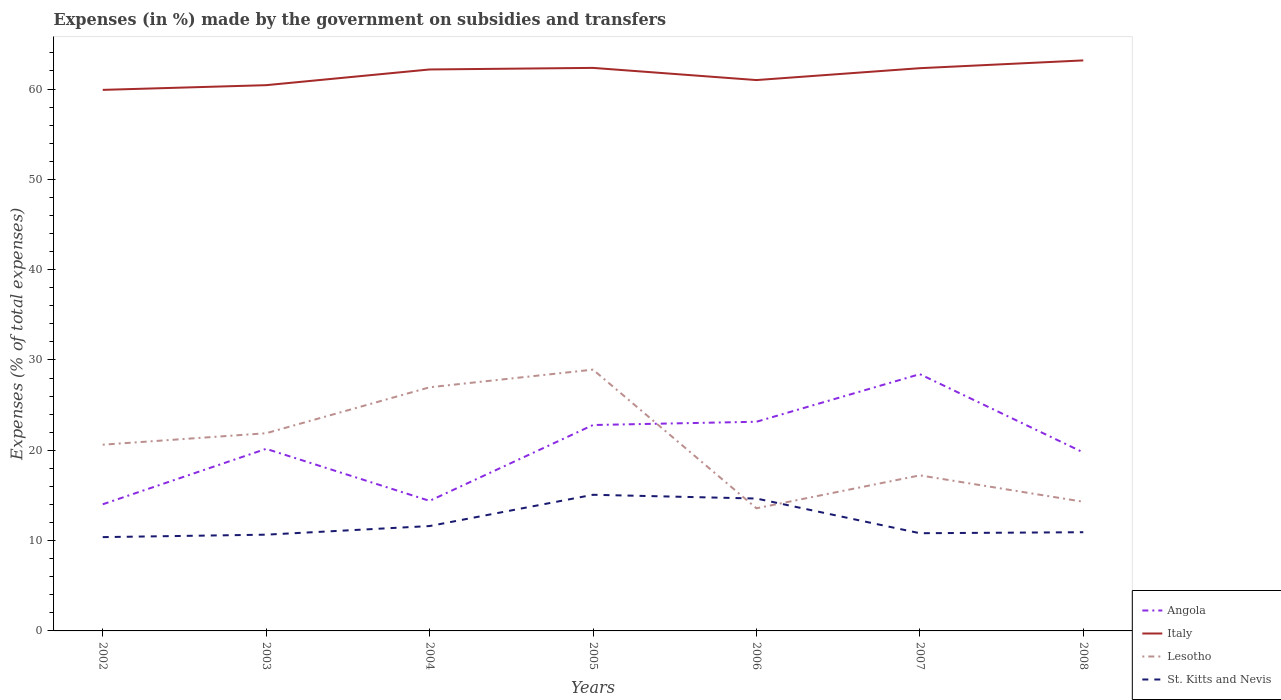How many different coloured lines are there?
Make the answer very short. 4. Does the line corresponding to Lesotho intersect with the line corresponding to Angola?
Offer a terse response. Yes. Is the number of lines equal to the number of legend labels?
Make the answer very short. Yes. Across all years, what is the maximum percentage of expenses made by the government on subsidies and transfers in Lesotho?
Ensure brevity in your answer.  13.58. In which year was the percentage of expenses made by the government on subsidies and transfers in Lesotho maximum?
Make the answer very short. 2006. What is the total percentage of expenses made by the government on subsidies and transfers in St. Kitts and Nevis in the graph?
Offer a very short reply. 0.79. What is the difference between the highest and the second highest percentage of expenses made by the government on subsidies and transfers in Angola?
Your answer should be compact. 14.41. Is the percentage of expenses made by the government on subsidies and transfers in Angola strictly greater than the percentage of expenses made by the government on subsidies and transfers in Italy over the years?
Your answer should be very brief. Yes. How many years are there in the graph?
Provide a succinct answer. 7. What is the difference between two consecutive major ticks on the Y-axis?
Ensure brevity in your answer.  10. Are the values on the major ticks of Y-axis written in scientific E-notation?
Give a very brief answer. No. Does the graph contain grids?
Your answer should be very brief. No. How are the legend labels stacked?
Your answer should be compact. Vertical. What is the title of the graph?
Make the answer very short. Expenses (in %) made by the government on subsidies and transfers. What is the label or title of the Y-axis?
Your answer should be very brief. Expenses (% of total expenses). What is the Expenses (% of total expenses) of Angola in 2002?
Offer a terse response. 14.02. What is the Expenses (% of total expenses) in Italy in 2002?
Make the answer very short. 59.91. What is the Expenses (% of total expenses) of Lesotho in 2002?
Provide a short and direct response. 20.62. What is the Expenses (% of total expenses) of St. Kitts and Nevis in 2002?
Your answer should be compact. 10.39. What is the Expenses (% of total expenses) in Angola in 2003?
Your answer should be very brief. 20.16. What is the Expenses (% of total expenses) of Italy in 2003?
Provide a succinct answer. 60.43. What is the Expenses (% of total expenses) in Lesotho in 2003?
Make the answer very short. 21.89. What is the Expenses (% of total expenses) of St. Kitts and Nevis in 2003?
Your answer should be very brief. 10.66. What is the Expenses (% of total expenses) in Angola in 2004?
Ensure brevity in your answer.  14.4. What is the Expenses (% of total expenses) in Italy in 2004?
Your answer should be compact. 62.17. What is the Expenses (% of total expenses) in Lesotho in 2004?
Provide a short and direct response. 26.98. What is the Expenses (% of total expenses) in St. Kitts and Nevis in 2004?
Make the answer very short. 11.61. What is the Expenses (% of total expenses) in Angola in 2005?
Offer a terse response. 22.8. What is the Expenses (% of total expenses) in Italy in 2005?
Keep it short and to the point. 62.34. What is the Expenses (% of total expenses) of Lesotho in 2005?
Offer a terse response. 28.93. What is the Expenses (% of total expenses) in St. Kitts and Nevis in 2005?
Provide a succinct answer. 15.08. What is the Expenses (% of total expenses) in Angola in 2006?
Provide a short and direct response. 23.16. What is the Expenses (% of total expenses) in Italy in 2006?
Provide a short and direct response. 60.99. What is the Expenses (% of total expenses) in Lesotho in 2006?
Your response must be concise. 13.58. What is the Expenses (% of total expenses) of St. Kitts and Nevis in 2006?
Make the answer very short. 14.66. What is the Expenses (% of total expenses) of Angola in 2007?
Your answer should be compact. 28.43. What is the Expenses (% of total expenses) of Italy in 2007?
Provide a short and direct response. 62.31. What is the Expenses (% of total expenses) of Lesotho in 2007?
Your response must be concise. 17.23. What is the Expenses (% of total expenses) in St. Kitts and Nevis in 2007?
Keep it short and to the point. 10.82. What is the Expenses (% of total expenses) in Angola in 2008?
Ensure brevity in your answer.  19.76. What is the Expenses (% of total expenses) in Italy in 2008?
Make the answer very short. 63.17. What is the Expenses (% of total expenses) of Lesotho in 2008?
Make the answer very short. 14.3. What is the Expenses (% of total expenses) of St. Kitts and Nevis in 2008?
Provide a succinct answer. 10.93. Across all years, what is the maximum Expenses (% of total expenses) of Angola?
Your answer should be compact. 28.43. Across all years, what is the maximum Expenses (% of total expenses) of Italy?
Give a very brief answer. 63.17. Across all years, what is the maximum Expenses (% of total expenses) of Lesotho?
Your response must be concise. 28.93. Across all years, what is the maximum Expenses (% of total expenses) in St. Kitts and Nevis?
Provide a succinct answer. 15.08. Across all years, what is the minimum Expenses (% of total expenses) of Angola?
Your response must be concise. 14.02. Across all years, what is the minimum Expenses (% of total expenses) in Italy?
Make the answer very short. 59.91. Across all years, what is the minimum Expenses (% of total expenses) of Lesotho?
Your answer should be compact. 13.58. Across all years, what is the minimum Expenses (% of total expenses) of St. Kitts and Nevis?
Provide a short and direct response. 10.39. What is the total Expenses (% of total expenses) of Angola in the graph?
Offer a very short reply. 142.74. What is the total Expenses (% of total expenses) of Italy in the graph?
Provide a succinct answer. 431.32. What is the total Expenses (% of total expenses) of Lesotho in the graph?
Provide a short and direct response. 143.52. What is the total Expenses (% of total expenses) in St. Kitts and Nevis in the graph?
Your response must be concise. 84.14. What is the difference between the Expenses (% of total expenses) of Angola in 2002 and that in 2003?
Your answer should be very brief. -6.14. What is the difference between the Expenses (% of total expenses) of Italy in 2002 and that in 2003?
Offer a terse response. -0.52. What is the difference between the Expenses (% of total expenses) of Lesotho in 2002 and that in 2003?
Give a very brief answer. -1.27. What is the difference between the Expenses (% of total expenses) in St. Kitts and Nevis in 2002 and that in 2003?
Offer a very short reply. -0.27. What is the difference between the Expenses (% of total expenses) in Angola in 2002 and that in 2004?
Your answer should be compact. -0.38. What is the difference between the Expenses (% of total expenses) of Italy in 2002 and that in 2004?
Offer a terse response. -2.26. What is the difference between the Expenses (% of total expenses) of Lesotho in 2002 and that in 2004?
Give a very brief answer. -6.36. What is the difference between the Expenses (% of total expenses) of St. Kitts and Nevis in 2002 and that in 2004?
Provide a short and direct response. -1.23. What is the difference between the Expenses (% of total expenses) in Angola in 2002 and that in 2005?
Give a very brief answer. -8.78. What is the difference between the Expenses (% of total expenses) of Italy in 2002 and that in 2005?
Your answer should be compact. -2.43. What is the difference between the Expenses (% of total expenses) of Lesotho in 2002 and that in 2005?
Your response must be concise. -8.31. What is the difference between the Expenses (% of total expenses) of St. Kitts and Nevis in 2002 and that in 2005?
Give a very brief answer. -4.69. What is the difference between the Expenses (% of total expenses) in Angola in 2002 and that in 2006?
Give a very brief answer. -9.14. What is the difference between the Expenses (% of total expenses) in Italy in 2002 and that in 2006?
Give a very brief answer. -1.09. What is the difference between the Expenses (% of total expenses) of Lesotho in 2002 and that in 2006?
Keep it short and to the point. 7.04. What is the difference between the Expenses (% of total expenses) of St. Kitts and Nevis in 2002 and that in 2006?
Offer a terse response. -4.27. What is the difference between the Expenses (% of total expenses) of Angola in 2002 and that in 2007?
Your answer should be very brief. -14.41. What is the difference between the Expenses (% of total expenses) in Italy in 2002 and that in 2007?
Your answer should be very brief. -2.4. What is the difference between the Expenses (% of total expenses) in Lesotho in 2002 and that in 2007?
Provide a short and direct response. 3.39. What is the difference between the Expenses (% of total expenses) of St. Kitts and Nevis in 2002 and that in 2007?
Provide a succinct answer. -0.43. What is the difference between the Expenses (% of total expenses) in Angola in 2002 and that in 2008?
Give a very brief answer. -5.74. What is the difference between the Expenses (% of total expenses) of Italy in 2002 and that in 2008?
Ensure brevity in your answer.  -3.26. What is the difference between the Expenses (% of total expenses) of Lesotho in 2002 and that in 2008?
Ensure brevity in your answer.  6.32. What is the difference between the Expenses (% of total expenses) in St. Kitts and Nevis in 2002 and that in 2008?
Give a very brief answer. -0.54. What is the difference between the Expenses (% of total expenses) in Angola in 2003 and that in 2004?
Give a very brief answer. 5.76. What is the difference between the Expenses (% of total expenses) of Italy in 2003 and that in 2004?
Keep it short and to the point. -1.74. What is the difference between the Expenses (% of total expenses) in Lesotho in 2003 and that in 2004?
Offer a very short reply. -5.09. What is the difference between the Expenses (% of total expenses) of St. Kitts and Nevis in 2003 and that in 2004?
Your answer should be very brief. -0.95. What is the difference between the Expenses (% of total expenses) in Angola in 2003 and that in 2005?
Your answer should be compact. -2.64. What is the difference between the Expenses (% of total expenses) in Italy in 2003 and that in 2005?
Provide a succinct answer. -1.91. What is the difference between the Expenses (% of total expenses) of Lesotho in 2003 and that in 2005?
Make the answer very short. -7.04. What is the difference between the Expenses (% of total expenses) of St. Kitts and Nevis in 2003 and that in 2005?
Keep it short and to the point. -4.42. What is the difference between the Expenses (% of total expenses) of Angola in 2003 and that in 2006?
Offer a terse response. -3. What is the difference between the Expenses (% of total expenses) of Italy in 2003 and that in 2006?
Give a very brief answer. -0.56. What is the difference between the Expenses (% of total expenses) of Lesotho in 2003 and that in 2006?
Give a very brief answer. 8.31. What is the difference between the Expenses (% of total expenses) of St. Kitts and Nevis in 2003 and that in 2006?
Keep it short and to the point. -4. What is the difference between the Expenses (% of total expenses) of Angola in 2003 and that in 2007?
Provide a short and direct response. -8.27. What is the difference between the Expenses (% of total expenses) of Italy in 2003 and that in 2007?
Your answer should be very brief. -1.88. What is the difference between the Expenses (% of total expenses) in Lesotho in 2003 and that in 2007?
Provide a succinct answer. 4.66. What is the difference between the Expenses (% of total expenses) of St. Kitts and Nevis in 2003 and that in 2007?
Provide a short and direct response. -0.16. What is the difference between the Expenses (% of total expenses) of Angola in 2003 and that in 2008?
Offer a very short reply. 0.4. What is the difference between the Expenses (% of total expenses) in Italy in 2003 and that in 2008?
Your answer should be very brief. -2.74. What is the difference between the Expenses (% of total expenses) in Lesotho in 2003 and that in 2008?
Provide a succinct answer. 7.59. What is the difference between the Expenses (% of total expenses) in St. Kitts and Nevis in 2003 and that in 2008?
Provide a short and direct response. -0.27. What is the difference between the Expenses (% of total expenses) of Angola in 2004 and that in 2005?
Your response must be concise. -8.4. What is the difference between the Expenses (% of total expenses) of Italy in 2004 and that in 2005?
Your answer should be compact. -0.17. What is the difference between the Expenses (% of total expenses) of Lesotho in 2004 and that in 2005?
Make the answer very short. -1.95. What is the difference between the Expenses (% of total expenses) in St. Kitts and Nevis in 2004 and that in 2005?
Offer a terse response. -3.46. What is the difference between the Expenses (% of total expenses) of Angola in 2004 and that in 2006?
Your answer should be very brief. -8.76. What is the difference between the Expenses (% of total expenses) in Italy in 2004 and that in 2006?
Your answer should be compact. 1.17. What is the difference between the Expenses (% of total expenses) of Lesotho in 2004 and that in 2006?
Offer a very short reply. 13.4. What is the difference between the Expenses (% of total expenses) of St. Kitts and Nevis in 2004 and that in 2006?
Ensure brevity in your answer.  -3.05. What is the difference between the Expenses (% of total expenses) in Angola in 2004 and that in 2007?
Keep it short and to the point. -14.03. What is the difference between the Expenses (% of total expenses) of Italy in 2004 and that in 2007?
Offer a very short reply. -0.14. What is the difference between the Expenses (% of total expenses) of Lesotho in 2004 and that in 2007?
Offer a very short reply. 9.75. What is the difference between the Expenses (% of total expenses) of St. Kitts and Nevis in 2004 and that in 2007?
Offer a terse response. 0.79. What is the difference between the Expenses (% of total expenses) of Angola in 2004 and that in 2008?
Offer a terse response. -5.36. What is the difference between the Expenses (% of total expenses) of Italy in 2004 and that in 2008?
Your answer should be compact. -1. What is the difference between the Expenses (% of total expenses) of Lesotho in 2004 and that in 2008?
Offer a terse response. 12.68. What is the difference between the Expenses (% of total expenses) in St. Kitts and Nevis in 2004 and that in 2008?
Ensure brevity in your answer.  0.68. What is the difference between the Expenses (% of total expenses) in Angola in 2005 and that in 2006?
Your response must be concise. -0.36. What is the difference between the Expenses (% of total expenses) in Italy in 2005 and that in 2006?
Offer a terse response. 1.35. What is the difference between the Expenses (% of total expenses) in Lesotho in 2005 and that in 2006?
Keep it short and to the point. 15.35. What is the difference between the Expenses (% of total expenses) of St. Kitts and Nevis in 2005 and that in 2006?
Your answer should be very brief. 0.42. What is the difference between the Expenses (% of total expenses) in Angola in 2005 and that in 2007?
Provide a short and direct response. -5.63. What is the difference between the Expenses (% of total expenses) in Italy in 2005 and that in 2007?
Provide a succinct answer. 0.03. What is the difference between the Expenses (% of total expenses) of Lesotho in 2005 and that in 2007?
Your response must be concise. 11.7. What is the difference between the Expenses (% of total expenses) in St. Kitts and Nevis in 2005 and that in 2007?
Ensure brevity in your answer.  4.26. What is the difference between the Expenses (% of total expenses) in Angola in 2005 and that in 2008?
Make the answer very short. 3.04. What is the difference between the Expenses (% of total expenses) of Italy in 2005 and that in 2008?
Your answer should be compact. -0.83. What is the difference between the Expenses (% of total expenses) of Lesotho in 2005 and that in 2008?
Provide a succinct answer. 14.63. What is the difference between the Expenses (% of total expenses) of St. Kitts and Nevis in 2005 and that in 2008?
Offer a terse response. 4.15. What is the difference between the Expenses (% of total expenses) in Angola in 2006 and that in 2007?
Keep it short and to the point. -5.27. What is the difference between the Expenses (% of total expenses) of Italy in 2006 and that in 2007?
Give a very brief answer. -1.32. What is the difference between the Expenses (% of total expenses) of Lesotho in 2006 and that in 2007?
Your answer should be compact. -3.65. What is the difference between the Expenses (% of total expenses) in St. Kitts and Nevis in 2006 and that in 2007?
Keep it short and to the point. 3.84. What is the difference between the Expenses (% of total expenses) of Angola in 2006 and that in 2008?
Offer a terse response. 3.4. What is the difference between the Expenses (% of total expenses) of Italy in 2006 and that in 2008?
Offer a terse response. -2.18. What is the difference between the Expenses (% of total expenses) of Lesotho in 2006 and that in 2008?
Provide a succinct answer. -0.72. What is the difference between the Expenses (% of total expenses) of St. Kitts and Nevis in 2006 and that in 2008?
Provide a succinct answer. 3.73. What is the difference between the Expenses (% of total expenses) in Angola in 2007 and that in 2008?
Give a very brief answer. 8.67. What is the difference between the Expenses (% of total expenses) of Italy in 2007 and that in 2008?
Your response must be concise. -0.86. What is the difference between the Expenses (% of total expenses) of Lesotho in 2007 and that in 2008?
Offer a very short reply. 2.92. What is the difference between the Expenses (% of total expenses) of St. Kitts and Nevis in 2007 and that in 2008?
Provide a short and direct response. -0.11. What is the difference between the Expenses (% of total expenses) of Angola in 2002 and the Expenses (% of total expenses) of Italy in 2003?
Your answer should be very brief. -46.41. What is the difference between the Expenses (% of total expenses) in Angola in 2002 and the Expenses (% of total expenses) in Lesotho in 2003?
Your answer should be very brief. -7.87. What is the difference between the Expenses (% of total expenses) of Angola in 2002 and the Expenses (% of total expenses) of St. Kitts and Nevis in 2003?
Your answer should be compact. 3.37. What is the difference between the Expenses (% of total expenses) of Italy in 2002 and the Expenses (% of total expenses) of Lesotho in 2003?
Your answer should be very brief. 38.02. What is the difference between the Expenses (% of total expenses) of Italy in 2002 and the Expenses (% of total expenses) of St. Kitts and Nevis in 2003?
Offer a terse response. 49.25. What is the difference between the Expenses (% of total expenses) of Lesotho in 2002 and the Expenses (% of total expenses) of St. Kitts and Nevis in 2003?
Keep it short and to the point. 9.96. What is the difference between the Expenses (% of total expenses) of Angola in 2002 and the Expenses (% of total expenses) of Italy in 2004?
Make the answer very short. -48.14. What is the difference between the Expenses (% of total expenses) in Angola in 2002 and the Expenses (% of total expenses) in Lesotho in 2004?
Your response must be concise. -12.95. What is the difference between the Expenses (% of total expenses) in Angola in 2002 and the Expenses (% of total expenses) in St. Kitts and Nevis in 2004?
Offer a terse response. 2.41. What is the difference between the Expenses (% of total expenses) of Italy in 2002 and the Expenses (% of total expenses) of Lesotho in 2004?
Your response must be concise. 32.93. What is the difference between the Expenses (% of total expenses) of Italy in 2002 and the Expenses (% of total expenses) of St. Kitts and Nevis in 2004?
Offer a terse response. 48.3. What is the difference between the Expenses (% of total expenses) of Lesotho in 2002 and the Expenses (% of total expenses) of St. Kitts and Nevis in 2004?
Offer a very short reply. 9.01. What is the difference between the Expenses (% of total expenses) of Angola in 2002 and the Expenses (% of total expenses) of Italy in 2005?
Your answer should be compact. -48.32. What is the difference between the Expenses (% of total expenses) in Angola in 2002 and the Expenses (% of total expenses) in Lesotho in 2005?
Offer a very short reply. -14.91. What is the difference between the Expenses (% of total expenses) in Angola in 2002 and the Expenses (% of total expenses) in St. Kitts and Nevis in 2005?
Offer a terse response. -1.05. What is the difference between the Expenses (% of total expenses) of Italy in 2002 and the Expenses (% of total expenses) of Lesotho in 2005?
Your answer should be compact. 30.98. What is the difference between the Expenses (% of total expenses) of Italy in 2002 and the Expenses (% of total expenses) of St. Kitts and Nevis in 2005?
Your answer should be compact. 44.83. What is the difference between the Expenses (% of total expenses) of Lesotho in 2002 and the Expenses (% of total expenses) of St. Kitts and Nevis in 2005?
Provide a short and direct response. 5.54. What is the difference between the Expenses (% of total expenses) in Angola in 2002 and the Expenses (% of total expenses) in Italy in 2006?
Your response must be concise. -46.97. What is the difference between the Expenses (% of total expenses) of Angola in 2002 and the Expenses (% of total expenses) of Lesotho in 2006?
Keep it short and to the point. 0.44. What is the difference between the Expenses (% of total expenses) in Angola in 2002 and the Expenses (% of total expenses) in St. Kitts and Nevis in 2006?
Provide a short and direct response. -0.64. What is the difference between the Expenses (% of total expenses) of Italy in 2002 and the Expenses (% of total expenses) of Lesotho in 2006?
Ensure brevity in your answer.  46.33. What is the difference between the Expenses (% of total expenses) in Italy in 2002 and the Expenses (% of total expenses) in St. Kitts and Nevis in 2006?
Make the answer very short. 45.25. What is the difference between the Expenses (% of total expenses) of Lesotho in 2002 and the Expenses (% of total expenses) of St. Kitts and Nevis in 2006?
Offer a terse response. 5.96. What is the difference between the Expenses (% of total expenses) in Angola in 2002 and the Expenses (% of total expenses) in Italy in 2007?
Offer a very short reply. -48.29. What is the difference between the Expenses (% of total expenses) in Angola in 2002 and the Expenses (% of total expenses) in Lesotho in 2007?
Keep it short and to the point. -3.2. What is the difference between the Expenses (% of total expenses) in Angola in 2002 and the Expenses (% of total expenses) in St. Kitts and Nevis in 2007?
Provide a short and direct response. 3.21. What is the difference between the Expenses (% of total expenses) of Italy in 2002 and the Expenses (% of total expenses) of Lesotho in 2007?
Offer a terse response. 42.68. What is the difference between the Expenses (% of total expenses) of Italy in 2002 and the Expenses (% of total expenses) of St. Kitts and Nevis in 2007?
Your answer should be compact. 49.09. What is the difference between the Expenses (% of total expenses) in Lesotho in 2002 and the Expenses (% of total expenses) in St. Kitts and Nevis in 2007?
Provide a short and direct response. 9.8. What is the difference between the Expenses (% of total expenses) in Angola in 2002 and the Expenses (% of total expenses) in Italy in 2008?
Offer a very short reply. -49.15. What is the difference between the Expenses (% of total expenses) of Angola in 2002 and the Expenses (% of total expenses) of Lesotho in 2008?
Make the answer very short. -0.28. What is the difference between the Expenses (% of total expenses) of Angola in 2002 and the Expenses (% of total expenses) of St. Kitts and Nevis in 2008?
Ensure brevity in your answer.  3.09. What is the difference between the Expenses (% of total expenses) in Italy in 2002 and the Expenses (% of total expenses) in Lesotho in 2008?
Offer a very short reply. 45.61. What is the difference between the Expenses (% of total expenses) of Italy in 2002 and the Expenses (% of total expenses) of St. Kitts and Nevis in 2008?
Your answer should be very brief. 48.98. What is the difference between the Expenses (% of total expenses) of Lesotho in 2002 and the Expenses (% of total expenses) of St. Kitts and Nevis in 2008?
Ensure brevity in your answer.  9.69. What is the difference between the Expenses (% of total expenses) in Angola in 2003 and the Expenses (% of total expenses) in Italy in 2004?
Your answer should be very brief. -42.01. What is the difference between the Expenses (% of total expenses) in Angola in 2003 and the Expenses (% of total expenses) in Lesotho in 2004?
Ensure brevity in your answer.  -6.82. What is the difference between the Expenses (% of total expenses) of Angola in 2003 and the Expenses (% of total expenses) of St. Kitts and Nevis in 2004?
Ensure brevity in your answer.  8.55. What is the difference between the Expenses (% of total expenses) in Italy in 2003 and the Expenses (% of total expenses) in Lesotho in 2004?
Provide a short and direct response. 33.45. What is the difference between the Expenses (% of total expenses) in Italy in 2003 and the Expenses (% of total expenses) in St. Kitts and Nevis in 2004?
Provide a short and direct response. 48.82. What is the difference between the Expenses (% of total expenses) of Lesotho in 2003 and the Expenses (% of total expenses) of St. Kitts and Nevis in 2004?
Provide a succinct answer. 10.28. What is the difference between the Expenses (% of total expenses) of Angola in 2003 and the Expenses (% of total expenses) of Italy in 2005?
Your answer should be compact. -42.18. What is the difference between the Expenses (% of total expenses) in Angola in 2003 and the Expenses (% of total expenses) in Lesotho in 2005?
Offer a very short reply. -8.77. What is the difference between the Expenses (% of total expenses) of Angola in 2003 and the Expenses (% of total expenses) of St. Kitts and Nevis in 2005?
Keep it short and to the point. 5.09. What is the difference between the Expenses (% of total expenses) of Italy in 2003 and the Expenses (% of total expenses) of Lesotho in 2005?
Your response must be concise. 31.5. What is the difference between the Expenses (% of total expenses) in Italy in 2003 and the Expenses (% of total expenses) in St. Kitts and Nevis in 2005?
Make the answer very short. 45.35. What is the difference between the Expenses (% of total expenses) of Lesotho in 2003 and the Expenses (% of total expenses) of St. Kitts and Nevis in 2005?
Ensure brevity in your answer.  6.81. What is the difference between the Expenses (% of total expenses) in Angola in 2003 and the Expenses (% of total expenses) in Italy in 2006?
Make the answer very short. -40.83. What is the difference between the Expenses (% of total expenses) in Angola in 2003 and the Expenses (% of total expenses) in Lesotho in 2006?
Give a very brief answer. 6.58. What is the difference between the Expenses (% of total expenses) in Angola in 2003 and the Expenses (% of total expenses) in St. Kitts and Nevis in 2006?
Make the answer very short. 5.5. What is the difference between the Expenses (% of total expenses) of Italy in 2003 and the Expenses (% of total expenses) of Lesotho in 2006?
Keep it short and to the point. 46.85. What is the difference between the Expenses (% of total expenses) in Italy in 2003 and the Expenses (% of total expenses) in St. Kitts and Nevis in 2006?
Your answer should be compact. 45.77. What is the difference between the Expenses (% of total expenses) in Lesotho in 2003 and the Expenses (% of total expenses) in St. Kitts and Nevis in 2006?
Offer a very short reply. 7.23. What is the difference between the Expenses (% of total expenses) in Angola in 2003 and the Expenses (% of total expenses) in Italy in 2007?
Make the answer very short. -42.15. What is the difference between the Expenses (% of total expenses) in Angola in 2003 and the Expenses (% of total expenses) in Lesotho in 2007?
Ensure brevity in your answer.  2.94. What is the difference between the Expenses (% of total expenses) of Angola in 2003 and the Expenses (% of total expenses) of St. Kitts and Nevis in 2007?
Your answer should be very brief. 9.34. What is the difference between the Expenses (% of total expenses) of Italy in 2003 and the Expenses (% of total expenses) of Lesotho in 2007?
Provide a succinct answer. 43.2. What is the difference between the Expenses (% of total expenses) in Italy in 2003 and the Expenses (% of total expenses) in St. Kitts and Nevis in 2007?
Ensure brevity in your answer.  49.61. What is the difference between the Expenses (% of total expenses) in Lesotho in 2003 and the Expenses (% of total expenses) in St. Kitts and Nevis in 2007?
Provide a succinct answer. 11.07. What is the difference between the Expenses (% of total expenses) of Angola in 2003 and the Expenses (% of total expenses) of Italy in 2008?
Your response must be concise. -43.01. What is the difference between the Expenses (% of total expenses) in Angola in 2003 and the Expenses (% of total expenses) in Lesotho in 2008?
Offer a very short reply. 5.86. What is the difference between the Expenses (% of total expenses) in Angola in 2003 and the Expenses (% of total expenses) in St. Kitts and Nevis in 2008?
Offer a very short reply. 9.23. What is the difference between the Expenses (% of total expenses) in Italy in 2003 and the Expenses (% of total expenses) in Lesotho in 2008?
Offer a very short reply. 46.13. What is the difference between the Expenses (% of total expenses) in Italy in 2003 and the Expenses (% of total expenses) in St. Kitts and Nevis in 2008?
Offer a terse response. 49.5. What is the difference between the Expenses (% of total expenses) of Lesotho in 2003 and the Expenses (% of total expenses) of St. Kitts and Nevis in 2008?
Make the answer very short. 10.96. What is the difference between the Expenses (% of total expenses) in Angola in 2004 and the Expenses (% of total expenses) in Italy in 2005?
Provide a short and direct response. -47.94. What is the difference between the Expenses (% of total expenses) of Angola in 2004 and the Expenses (% of total expenses) of Lesotho in 2005?
Your answer should be compact. -14.53. What is the difference between the Expenses (% of total expenses) in Angola in 2004 and the Expenses (% of total expenses) in St. Kitts and Nevis in 2005?
Your response must be concise. -0.68. What is the difference between the Expenses (% of total expenses) in Italy in 2004 and the Expenses (% of total expenses) in Lesotho in 2005?
Give a very brief answer. 33.24. What is the difference between the Expenses (% of total expenses) in Italy in 2004 and the Expenses (% of total expenses) in St. Kitts and Nevis in 2005?
Your response must be concise. 47.09. What is the difference between the Expenses (% of total expenses) in Lesotho in 2004 and the Expenses (% of total expenses) in St. Kitts and Nevis in 2005?
Your response must be concise. 11.9. What is the difference between the Expenses (% of total expenses) in Angola in 2004 and the Expenses (% of total expenses) in Italy in 2006?
Your response must be concise. -46.59. What is the difference between the Expenses (% of total expenses) of Angola in 2004 and the Expenses (% of total expenses) of Lesotho in 2006?
Offer a terse response. 0.82. What is the difference between the Expenses (% of total expenses) in Angola in 2004 and the Expenses (% of total expenses) in St. Kitts and Nevis in 2006?
Make the answer very short. -0.26. What is the difference between the Expenses (% of total expenses) of Italy in 2004 and the Expenses (% of total expenses) of Lesotho in 2006?
Ensure brevity in your answer.  48.59. What is the difference between the Expenses (% of total expenses) of Italy in 2004 and the Expenses (% of total expenses) of St. Kitts and Nevis in 2006?
Your answer should be very brief. 47.51. What is the difference between the Expenses (% of total expenses) in Lesotho in 2004 and the Expenses (% of total expenses) in St. Kitts and Nevis in 2006?
Your answer should be compact. 12.32. What is the difference between the Expenses (% of total expenses) of Angola in 2004 and the Expenses (% of total expenses) of Italy in 2007?
Provide a short and direct response. -47.91. What is the difference between the Expenses (% of total expenses) in Angola in 2004 and the Expenses (% of total expenses) in Lesotho in 2007?
Offer a terse response. -2.83. What is the difference between the Expenses (% of total expenses) in Angola in 2004 and the Expenses (% of total expenses) in St. Kitts and Nevis in 2007?
Your answer should be very brief. 3.58. What is the difference between the Expenses (% of total expenses) of Italy in 2004 and the Expenses (% of total expenses) of Lesotho in 2007?
Provide a short and direct response. 44.94. What is the difference between the Expenses (% of total expenses) in Italy in 2004 and the Expenses (% of total expenses) in St. Kitts and Nevis in 2007?
Make the answer very short. 51.35. What is the difference between the Expenses (% of total expenses) of Lesotho in 2004 and the Expenses (% of total expenses) of St. Kitts and Nevis in 2007?
Your answer should be compact. 16.16. What is the difference between the Expenses (% of total expenses) in Angola in 2004 and the Expenses (% of total expenses) in Italy in 2008?
Your answer should be compact. -48.77. What is the difference between the Expenses (% of total expenses) in Angola in 2004 and the Expenses (% of total expenses) in Lesotho in 2008?
Make the answer very short. 0.1. What is the difference between the Expenses (% of total expenses) in Angola in 2004 and the Expenses (% of total expenses) in St. Kitts and Nevis in 2008?
Your answer should be compact. 3.47. What is the difference between the Expenses (% of total expenses) in Italy in 2004 and the Expenses (% of total expenses) in Lesotho in 2008?
Your response must be concise. 47.87. What is the difference between the Expenses (% of total expenses) of Italy in 2004 and the Expenses (% of total expenses) of St. Kitts and Nevis in 2008?
Your answer should be very brief. 51.24. What is the difference between the Expenses (% of total expenses) of Lesotho in 2004 and the Expenses (% of total expenses) of St. Kitts and Nevis in 2008?
Give a very brief answer. 16.05. What is the difference between the Expenses (% of total expenses) of Angola in 2005 and the Expenses (% of total expenses) of Italy in 2006?
Keep it short and to the point. -38.19. What is the difference between the Expenses (% of total expenses) in Angola in 2005 and the Expenses (% of total expenses) in Lesotho in 2006?
Your response must be concise. 9.22. What is the difference between the Expenses (% of total expenses) in Angola in 2005 and the Expenses (% of total expenses) in St. Kitts and Nevis in 2006?
Offer a terse response. 8.14. What is the difference between the Expenses (% of total expenses) of Italy in 2005 and the Expenses (% of total expenses) of Lesotho in 2006?
Ensure brevity in your answer.  48.76. What is the difference between the Expenses (% of total expenses) in Italy in 2005 and the Expenses (% of total expenses) in St. Kitts and Nevis in 2006?
Your answer should be very brief. 47.68. What is the difference between the Expenses (% of total expenses) of Lesotho in 2005 and the Expenses (% of total expenses) of St. Kitts and Nevis in 2006?
Make the answer very short. 14.27. What is the difference between the Expenses (% of total expenses) of Angola in 2005 and the Expenses (% of total expenses) of Italy in 2007?
Give a very brief answer. -39.51. What is the difference between the Expenses (% of total expenses) of Angola in 2005 and the Expenses (% of total expenses) of Lesotho in 2007?
Provide a succinct answer. 5.57. What is the difference between the Expenses (% of total expenses) in Angola in 2005 and the Expenses (% of total expenses) in St. Kitts and Nevis in 2007?
Give a very brief answer. 11.98. What is the difference between the Expenses (% of total expenses) of Italy in 2005 and the Expenses (% of total expenses) of Lesotho in 2007?
Keep it short and to the point. 45.12. What is the difference between the Expenses (% of total expenses) of Italy in 2005 and the Expenses (% of total expenses) of St. Kitts and Nevis in 2007?
Your answer should be very brief. 51.52. What is the difference between the Expenses (% of total expenses) of Lesotho in 2005 and the Expenses (% of total expenses) of St. Kitts and Nevis in 2007?
Your answer should be very brief. 18.11. What is the difference between the Expenses (% of total expenses) of Angola in 2005 and the Expenses (% of total expenses) of Italy in 2008?
Give a very brief answer. -40.37. What is the difference between the Expenses (% of total expenses) in Angola in 2005 and the Expenses (% of total expenses) in Lesotho in 2008?
Offer a very short reply. 8.5. What is the difference between the Expenses (% of total expenses) in Angola in 2005 and the Expenses (% of total expenses) in St. Kitts and Nevis in 2008?
Ensure brevity in your answer.  11.87. What is the difference between the Expenses (% of total expenses) of Italy in 2005 and the Expenses (% of total expenses) of Lesotho in 2008?
Offer a very short reply. 48.04. What is the difference between the Expenses (% of total expenses) of Italy in 2005 and the Expenses (% of total expenses) of St. Kitts and Nevis in 2008?
Give a very brief answer. 51.41. What is the difference between the Expenses (% of total expenses) of Lesotho in 2005 and the Expenses (% of total expenses) of St. Kitts and Nevis in 2008?
Your response must be concise. 18. What is the difference between the Expenses (% of total expenses) in Angola in 2006 and the Expenses (% of total expenses) in Italy in 2007?
Your answer should be very brief. -39.15. What is the difference between the Expenses (% of total expenses) of Angola in 2006 and the Expenses (% of total expenses) of Lesotho in 2007?
Ensure brevity in your answer.  5.94. What is the difference between the Expenses (% of total expenses) of Angola in 2006 and the Expenses (% of total expenses) of St. Kitts and Nevis in 2007?
Your answer should be compact. 12.34. What is the difference between the Expenses (% of total expenses) of Italy in 2006 and the Expenses (% of total expenses) of Lesotho in 2007?
Give a very brief answer. 43.77. What is the difference between the Expenses (% of total expenses) in Italy in 2006 and the Expenses (% of total expenses) in St. Kitts and Nevis in 2007?
Make the answer very short. 50.18. What is the difference between the Expenses (% of total expenses) of Lesotho in 2006 and the Expenses (% of total expenses) of St. Kitts and Nevis in 2007?
Ensure brevity in your answer.  2.76. What is the difference between the Expenses (% of total expenses) in Angola in 2006 and the Expenses (% of total expenses) in Italy in 2008?
Your answer should be compact. -40.01. What is the difference between the Expenses (% of total expenses) in Angola in 2006 and the Expenses (% of total expenses) in Lesotho in 2008?
Your answer should be very brief. 8.86. What is the difference between the Expenses (% of total expenses) of Angola in 2006 and the Expenses (% of total expenses) of St. Kitts and Nevis in 2008?
Make the answer very short. 12.23. What is the difference between the Expenses (% of total expenses) of Italy in 2006 and the Expenses (% of total expenses) of Lesotho in 2008?
Provide a succinct answer. 46.69. What is the difference between the Expenses (% of total expenses) in Italy in 2006 and the Expenses (% of total expenses) in St. Kitts and Nevis in 2008?
Your response must be concise. 50.06. What is the difference between the Expenses (% of total expenses) of Lesotho in 2006 and the Expenses (% of total expenses) of St. Kitts and Nevis in 2008?
Keep it short and to the point. 2.65. What is the difference between the Expenses (% of total expenses) of Angola in 2007 and the Expenses (% of total expenses) of Italy in 2008?
Your response must be concise. -34.74. What is the difference between the Expenses (% of total expenses) in Angola in 2007 and the Expenses (% of total expenses) in Lesotho in 2008?
Offer a terse response. 14.13. What is the difference between the Expenses (% of total expenses) in Angola in 2007 and the Expenses (% of total expenses) in St. Kitts and Nevis in 2008?
Your answer should be compact. 17.5. What is the difference between the Expenses (% of total expenses) of Italy in 2007 and the Expenses (% of total expenses) of Lesotho in 2008?
Your answer should be compact. 48.01. What is the difference between the Expenses (% of total expenses) in Italy in 2007 and the Expenses (% of total expenses) in St. Kitts and Nevis in 2008?
Make the answer very short. 51.38. What is the difference between the Expenses (% of total expenses) of Lesotho in 2007 and the Expenses (% of total expenses) of St. Kitts and Nevis in 2008?
Offer a very short reply. 6.3. What is the average Expenses (% of total expenses) of Angola per year?
Ensure brevity in your answer.  20.39. What is the average Expenses (% of total expenses) of Italy per year?
Offer a terse response. 61.62. What is the average Expenses (% of total expenses) of Lesotho per year?
Provide a short and direct response. 20.5. What is the average Expenses (% of total expenses) of St. Kitts and Nevis per year?
Your answer should be compact. 12.02. In the year 2002, what is the difference between the Expenses (% of total expenses) of Angola and Expenses (% of total expenses) of Italy?
Keep it short and to the point. -45.88. In the year 2002, what is the difference between the Expenses (% of total expenses) of Angola and Expenses (% of total expenses) of Lesotho?
Offer a very short reply. -6.6. In the year 2002, what is the difference between the Expenses (% of total expenses) of Angola and Expenses (% of total expenses) of St. Kitts and Nevis?
Give a very brief answer. 3.64. In the year 2002, what is the difference between the Expenses (% of total expenses) of Italy and Expenses (% of total expenses) of Lesotho?
Your answer should be compact. 39.29. In the year 2002, what is the difference between the Expenses (% of total expenses) in Italy and Expenses (% of total expenses) in St. Kitts and Nevis?
Offer a terse response. 49.52. In the year 2002, what is the difference between the Expenses (% of total expenses) of Lesotho and Expenses (% of total expenses) of St. Kitts and Nevis?
Your answer should be very brief. 10.23. In the year 2003, what is the difference between the Expenses (% of total expenses) of Angola and Expenses (% of total expenses) of Italy?
Your answer should be compact. -40.27. In the year 2003, what is the difference between the Expenses (% of total expenses) in Angola and Expenses (% of total expenses) in Lesotho?
Your answer should be very brief. -1.73. In the year 2003, what is the difference between the Expenses (% of total expenses) of Angola and Expenses (% of total expenses) of St. Kitts and Nevis?
Provide a succinct answer. 9.5. In the year 2003, what is the difference between the Expenses (% of total expenses) of Italy and Expenses (% of total expenses) of Lesotho?
Provide a short and direct response. 38.54. In the year 2003, what is the difference between the Expenses (% of total expenses) in Italy and Expenses (% of total expenses) in St. Kitts and Nevis?
Give a very brief answer. 49.77. In the year 2003, what is the difference between the Expenses (% of total expenses) of Lesotho and Expenses (% of total expenses) of St. Kitts and Nevis?
Offer a very short reply. 11.23. In the year 2004, what is the difference between the Expenses (% of total expenses) in Angola and Expenses (% of total expenses) in Italy?
Make the answer very short. -47.77. In the year 2004, what is the difference between the Expenses (% of total expenses) in Angola and Expenses (% of total expenses) in Lesotho?
Keep it short and to the point. -12.58. In the year 2004, what is the difference between the Expenses (% of total expenses) in Angola and Expenses (% of total expenses) in St. Kitts and Nevis?
Your answer should be compact. 2.79. In the year 2004, what is the difference between the Expenses (% of total expenses) of Italy and Expenses (% of total expenses) of Lesotho?
Your response must be concise. 35.19. In the year 2004, what is the difference between the Expenses (% of total expenses) of Italy and Expenses (% of total expenses) of St. Kitts and Nevis?
Offer a very short reply. 50.56. In the year 2004, what is the difference between the Expenses (% of total expenses) of Lesotho and Expenses (% of total expenses) of St. Kitts and Nevis?
Your answer should be very brief. 15.36. In the year 2005, what is the difference between the Expenses (% of total expenses) in Angola and Expenses (% of total expenses) in Italy?
Provide a succinct answer. -39.54. In the year 2005, what is the difference between the Expenses (% of total expenses) of Angola and Expenses (% of total expenses) of Lesotho?
Provide a succinct answer. -6.13. In the year 2005, what is the difference between the Expenses (% of total expenses) of Angola and Expenses (% of total expenses) of St. Kitts and Nevis?
Provide a short and direct response. 7.72. In the year 2005, what is the difference between the Expenses (% of total expenses) in Italy and Expenses (% of total expenses) in Lesotho?
Ensure brevity in your answer.  33.41. In the year 2005, what is the difference between the Expenses (% of total expenses) of Italy and Expenses (% of total expenses) of St. Kitts and Nevis?
Your answer should be compact. 47.27. In the year 2005, what is the difference between the Expenses (% of total expenses) in Lesotho and Expenses (% of total expenses) in St. Kitts and Nevis?
Offer a very short reply. 13.85. In the year 2006, what is the difference between the Expenses (% of total expenses) in Angola and Expenses (% of total expenses) in Italy?
Your answer should be compact. -37.83. In the year 2006, what is the difference between the Expenses (% of total expenses) in Angola and Expenses (% of total expenses) in Lesotho?
Your answer should be very brief. 9.58. In the year 2006, what is the difference between the Expenses (% of total expenses) of Angola and Expenses (% of total expenses) of St. Kitts and Nevis?
Your answer should be compact. 8.5. In the year 2006, what is the difference between the Expenses (% of total expenses) in Italy and Expenses (% of total expenses) in Lesotho?
Provide a succinct answer. 47.41. In the year 2006, what is the difference between the Expenses (% of total expenses) of Italy and Expenses (% of total expenses) of St. Kitts and Nevis?
Offer a terse response. 46.33. In the year 2006, what is the difference between the Expenses (% of total expenses) of Lesotho and Expenses (% of total expenses) of St. Kitts and Nevis?
Offer a very short reply. -1.08. In the year 2007, what is the difference between the Expenses (% of total expenses) of Angola and Expenses (% of total expenses) of Italy?
Make the answer very short. -33.88. In the year 2007, what is the difference between the Expenses (% of total expenses) of Angola and Expenses (% of total expenses) of Lesotho?
Your response must be concise. 11.21. In the year 2007, what is the difference between the Expenses (% of total expenses) in Angola and Expenses (% of total expenses) in St. Kitts and Nevis?
Your answer should be very brief. 17.61. In the year 2007, what is the difference between the Expenses (% of total expenses) in Italy and Expenses (% of total expenses) in Lesotho?
Your response must be concise. 45.08. In the year 2007, what is the difference between the Expenses (% of total expenses) in Italy and Expenses (% of total expenses) in St. Kitts and Nevis?
Keep it short and to the point. 51.49. In the year 2007, what is the difference between the Expenses (% of total expenses) in Lesotho and Expenses (% of total expenses) in St. Kitts and Nevis?
Your answer should be compact. 6.41. In the year 2008, what is the difference between the Expenses (% of total expenses) of Angola and Expenses (% of total expenses) of Italy?
Keep it short and to the point. -43.41. In the year 2008, what is the difference between the Expenses (% of total expenses) of Angola and Expenses (% of total expenses) of Lesotho?
Provide a short and direct response. 5.46. In the year 2008, what is the difference between the Expenses (% of total expenses) in Angola and Expenses (% of total expenses) in St. Kitts and Nevis?
Offer a terse response. 8.83. In the year 2008, what is the difference between the Expenses (% of total expenses) in Italy and Expenses (% of total expenses) in Lesotho?
Give a very brief answer. 48.87. In the year 2008, what is the difference between the Expenses (% of total expenses) in Italy and Expenses (% of total expenses) in St. Kitts and Nevis?
Offer a terse response. 52.24. In the year 2008, what is the difference between the Expenses (% of total expenses) in Lesotho and Expenses (% of total expenses) in St. Kitts and Nevis?
Your response must be concise. 3.37. What is the ratio of the Expenses (% of total expenses) of Angola in 2002 to that in 2003?
Provide a short and direct response. 0.7. What is the ratio of the Expenses (% of total expenses) in Italy in 2002 to that in 2003?
Keep it short and to the point. 0.99. What is the ratio of the Expenses (% of total expenses) of Lesotho in 2002 to that in 2003?
Provide a short and direct response. 0.94. What is the ratio of the Expenses (% of total expenses) in St. Kitts and Nevis in 2002 to that in 2003?
Ensure brevity in your answer.  0.97. What is the ratio of the Expenses (% of total expenses) in Angola in 2002 to that in 2004?
Your answer should be very brief. 0.97. What is the ratio of the Expenses (% of total expenses) of Italy in 2002 to that in 2004?
Offer a terse response. 0.96. What is the ratio of the Expenses (% of total expenses) of Lesotho in 2002 to that in 2004?
Ensure brevity in your answer.  0.76. What is the ratio of the Expenses (% of total expenses) of St. Kitts and Nevis in 2002 to that in 2004?
Provide a short and direct response. 0.89. What is the ratio of the Expenses (% of total expenses) in Angola in 2002 to that in 2005?
Offer a very short reply. 0.62. What is the ratio of the Expenses (% of total expenses) in Italy in 2002 to that in 2005?
Your answer should be compact. 0.96. What is the ratio of the Expenses (% of total expenses) in Lesotho in 2002 to that in 2005?
Provide a short and direct response. 0.71. What is the ratio of the Expenses (% of total expenses) in St. Kitts and Nevis in 2002 to that in 2005?
Ensure brevity in your answer.  0.69. What is the ratio of the Expenses (% of total expenses) in Angola in 2002 to that in 2006?
Offer a terse response. 0.61. What is the ratio of the Expenses (% of total expenses) of Italy in 2002 to that in 2006?
Keep it short and to the point. 0.98. What is the ratio of the Expenses (% of total expenses) of Lesotho in 2002 to that in 2006?
Ensure brevity in your answer.  1.52. What is the ratio of the Expenses (% of total expenses) in St. Kitts and Nevis in 2002 to that in 2006?
Offer a very short reply. 0.71. What is the ratio of the Expenses (% of total expenses) in Angola in 2002 to that in 2007?
Offer a terse response. 0.49. What is the ratio of the Expenses (% of total expenses) of Italy in 2002 to that in 2007?
Your response must be concise. 0.96. What is the ratio of the Expenses (% of total expenses) in Lesotho in 2002 to that in 2007?
Offer a terse response. 1.2. What is the ratio of the Expenses (% of total expenses) of St. Kitts and Nevis in 2002 to that in 2007?
Ensure brevity in your answer.  0.96. What is the ratio of the Expenses (% of total expenses) of Angola in 2002 to that in 2008?
Provide a succinct answer. 0.71. What is the ratio of the Expenses (% of total expenses) of Italy in 2002 to that in 2008?
Offer a very short reply. 0.95. What is the ratio of the Expenses (% of total expenses) in Lesotho in 2002 to that in 2008?
Give a very brief answer. 1.44. What is the ratio of the Expenses (% of total expenses) in St. Kitts and Nevis in 2002 to that in 2008?
Your answer should be compact. 0.95. What is the ratio of the Expenses (% of total expenses) in Angola in 2003 to that in 2004?
Ensure brevity in your answer.  1.4. What is the ratio of the Expenses (% of total expenses) of Italy in 2003 to that in 2004?
Make the answer very short. 0.97. What is the ratio of the Expenses (% of total expenses) in Lesotho in 2003 to that in 2004?
Offer a terse response. 0.81. What is the ratio of the Expenses (% of total expenses) of St. Kitts and Nevis in 2003 to that in 2004?
Ensure brevity in your answer.  0.92. What is the ratio of the Expenses (% of total expenses) in Angola in 2003 to that in 2005?
Offer a terse response. 0.88. What is the ratio of the Expenses (% of total expenses) of Italy in 2003 to that in 2005?
Your response must be concise. 0.97. What is the ratio of the Expenses (% of total expenses) of Lesotho in 2003 to that in 2005?
Offer a terse response. 0.76. What is the ratio of the Expenses (% of total expenses) of St. Kitts and Nevis in 2003 to that in 2005?
Provide a succinct answer. 0.71. What is the ratio of the Expenses (% of total expenses) of Angola in 2003 to that in 2006?
Offer a very short reply. 0.87. What is the ratio of the Expenses (% of total expenses) in Italy in 2003 to that in 2006?
Keep it short and to the point. 0.99. What is the ratio of the Expenses (% of total expenses) of Lesotho in 2003 to that in 2006?
Keep it short and to the point. 1.61. What is the ratio of the Expenses (% of total expenses) in St. Kitts and Nevis in 2003 to that in 2006?
Offer a terse response. 0.73. What is the ratio of the Expenses (% of total expenses) of Angola in 2003 to that in 2007?
Make the answer very short. 0.71. What is the ratio of the Expenses (% of total expenses) of Italy in 2003 to that in 2007?
Your answer should be compact. 0.97. What is the ratio of the Expenses (% of total expenses) of Lesotho in 2003 to that in 2007?
Give a very brief answer. 1.27. What is the ratio of the Expenses (% of total expenses) of St. Kitts and Nevis in 2003 to that in 2007?
Your answer should be compact. 0.99. What is the ratio of the Expenses (% of total expenses) of Angola in 2003 to that in 2008?
Give a very brief answer. 1.02. What is the ratio of the Expenses (% of total expenses) in Italy in 2003 to that in 2008?
Provide a succinct answer. 0.96. What is the ratio of the Expenses (% of total expenses) of Lesotho in 2003 to that in 2008?
Ensure brevity in your answer.  1.53. What is the ratio of the Expenses (% of total expenses) in St. Kitts and Nevis in 2003 to that in 2008?
Your response must be concise. 0.98. What is the ratio of the Expenses (% of total expenses) in Angola in 2004 to that in 2005?
Provide a succinct answer. 0.63. What is the ratio of the Expenses (% of total expenses) of Lesotho in 2004 to that in 2005?
Your answer should be compact. 0.93. What is the ratio of the Expenses (% of total expenses) in St. Kitts and Nevis in 2004 to that in 2005?
Keep it short and to the point. 0.77. What is the ratio of the Expenses (% of total expenses) in Angola in 2004 to that in 2006?
Your response must be concise. 0.62. What is the ratio of the Expenses (% of total expenses) of Italy in 2004 to that in 2006?
Your response must be concise. 1.02. What is the ratio of the Expenses (% of total expenses) in Lesotho in 2004 to that in 2006?
Ensure brevity in your answer.  1.99. What is the ratio of the Expenses (% of total expenses) in St. Kitts and Nevis in 2004 to that in 2006?
Keep it short and to the point. 0.79. What is the ratio of the Expenses (% of total expenses) of Angola in 2004 to that in 2007?
Your answer should be compact. 0.51. What is the ratio of the Expenses (% of total expenses) in Lesotho in 2004 to that in 2007?
Your answer should be very brief. 1.57. What is the ratio of the Expenses (% of total expenses) in St. Kitts and Nevis in 2004 to that in 2007?
Offer a terse response. 1.07. What is the ratio of the Expenses (% of total expenses) in Angola in 2004 to that in 2008?
Provide a succinct answer. 0.73. What is the ratio of the Expenses (% of total expenses) in Italy in 2004 to that in 2008?
Your answer should be compact. 0.98. What is the ratio of the Expenses (% of total expenses) in Lesotho in 2004 to that in 2008?
Ensure brevity in your answer.  1.89. What is the ratio of the Expenses (% of total expenses) of Angola in 2005 to that in 2006?
Make the answer very short. 0.98. What is the ratio of the Expenses (% of total expenses) of Italy in 2005 to that in 2006?
Provide a short and direct response. 1.02. What is the ratio of the Expenses (% of total expenses) in Lesotho in 2005 to that in 2006?
Ensure brevity in your answer.  2.13. What is the ratio of the Expenses (% of total expenses) of St. Kitts and Nevis in 2005 to that in 2006?
Keep it short and to the point. 1.03. What is the ratio of the Expenses (% of total expenses) of Angola in 2005 to that in 2007?
Your answer should be very brief. 0.8. What is the ratio of the Expenses (% of total expenses) of Lesotho in 2005 to that in 2007?
Your answer should be compact. 1.68. What is the ratio of the Expenses (% of total expenses) of St. Kitts and Nevis in 2005 to that in 2007?
Provide a succinct answer. 1.39. What is the ratio of the Expenses (% of total expenses) in Angola in 2005 to that in 2008?
Offer a terse response. 1.15. What is the ratio of the Expenses (% of total expenses) of Italy in 2005 to that in 2008?
Your response must be concise. 0.99. What is the ratio of the Expenses (% of total expenses) of Lesotho in 2005 to that in 2008?
Provide a succinct answer. 2.02. What is the ratio of the Expenses (% of total expenses) in St. Kitts and Nevis in 2005 to that in 2008?
Your answer should be compact. 1.38. What is the ratio of the Expenses (% of total expenses) of Angola in 2006 to that in 2007?
Ensure brevity in your answer.  0.81. What is the ratio of the Expenses (% of total expenses) of Italy in 2006 to that in 2007?
Your response must be concise. 0.98. What is the ratio of the Expenses (% of total expenses) in Lesotho in 2006 to that in 2007?
Give a very brief answer. 0.79. What is the ratio of the Expenses (% of total expenses) of St. Kitts and Nevis in 2006 to that in 2007?
Your answer should be very brief. 1.36. What is the ratio of the Expenses (% of total expenses) of Angola in 2006 to that in 2008?
Make the answer very short. 1.17. What is the ratio of the Expenses (% of total expenses) in Italy in 2006 to that in 2008?
Keep it short and to the point. 0.97. What is the ratio of the Expenses (% of total expenses) in Lesotho in 2006 to that in 2008?
Provide a short and direct response. 0.95. What is the ratio of the Expenses (% of total expenses) of St. Kitts and Nevis in 2006 to that in 2008?
Your response must be concise. 1.34. What is the ratio of the Expenses (% of total expenses) of Angola in 2007 to that in 2008?
Your answer should be very brief. 1.44. What is the ratio of the Expenses (% of total expenses) in Italy in 2007 to that in 2008?
Your answer should be compact. 0.99. What is the ratio of the Expenses (% of total expenses) of Lesotho in 2007 to that in 2008?
Your response must be concise. 1.2. What is the difference between the highest and the second highest Expenses (% of total expenses) of Angola?
Make the answer very short. 5.27. What is the difference between the highest and the second highest Expenses (% of total expenses) in Italy?
Make the answer very short. 0.83. What is the difference between the highest and the second highest Expenses (% of total expenses) of Lesotho?
Offer a terse response. 1.95. What is the difference between the highest and the second highest Expenses (% of total expenses) in St. Kitts and Nevis?
Provide a succinct answer. 0.42. What is the difference between the highest and the lowest Expenses (% of total expenses) of Angola?
Offer a terse response. 14.41. What is the difference between the highest and the lowest Expenses (% of total expenses) of Italy?
Offer a terse response. 3.26. What is the difference between the highest and the lowest Expenses (% of total expenses) of Lesotho?
Offer a terse response. 15.35. What is the difference between the highest and the lowest Expenses (% of total expenses) of St. Kitts and Nevis?
Offer a very short reply. 4.69. 